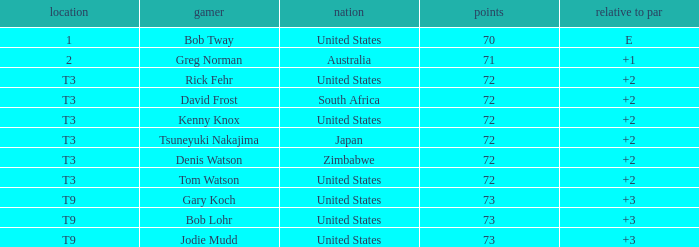What is the low score for TO par +2 in japan? 72.0. 